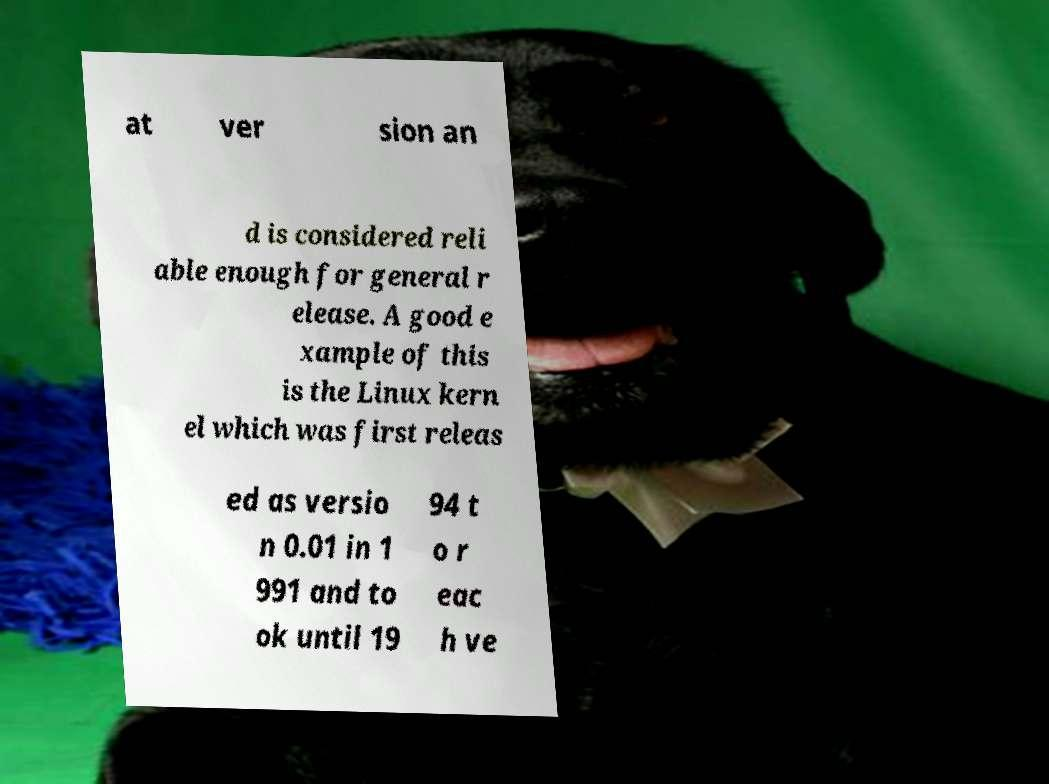Please identify and transcribe the text found in this image. at ver sion an d is considered reli able enough for general r elease. A good e xample of this is the Linux kern el which was first releas ed as versio n 0.01 in 1 991 and to ok until 19 94 t o r eac h ve 